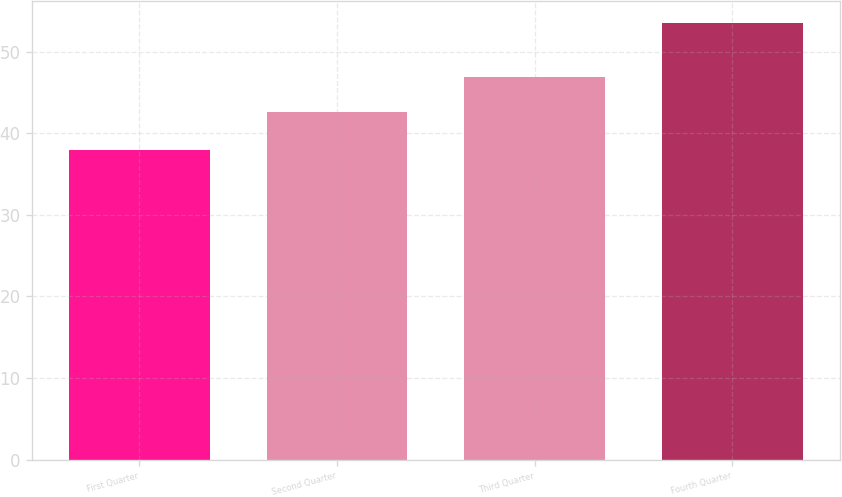Convert chart. <chart><loc_0><loc_0><loc_500><loc_500><bar_chart><fcel>First Quarter<fcel>Second Quarter<fcel>Third Quarter<fcel>Fourth Quarter<nl><fcel>37.95<fcel>42.54<fcel>46.87<fcel>53.54<nl></chart> 